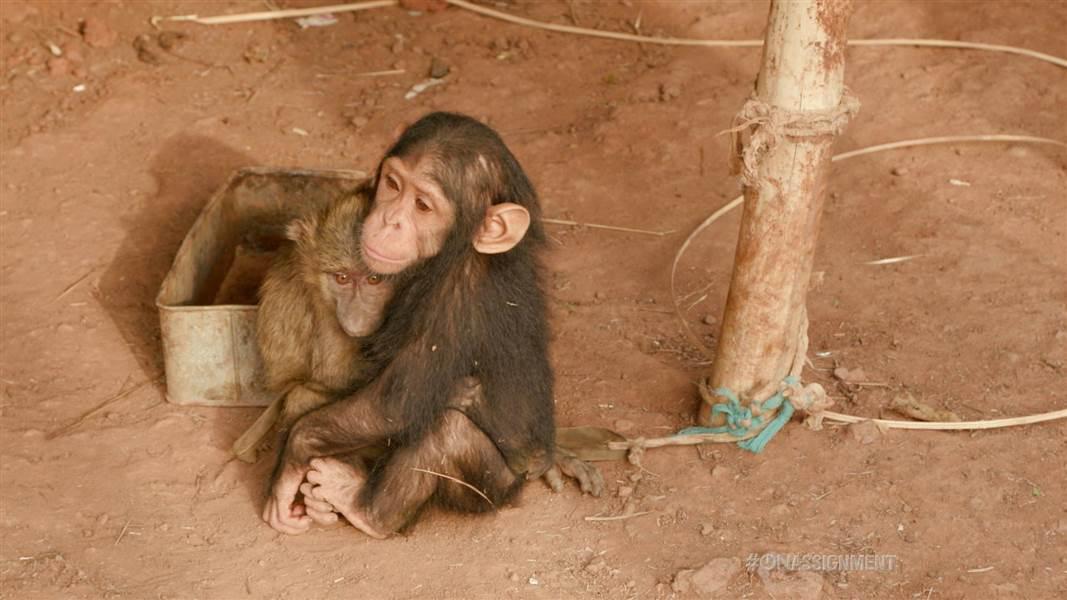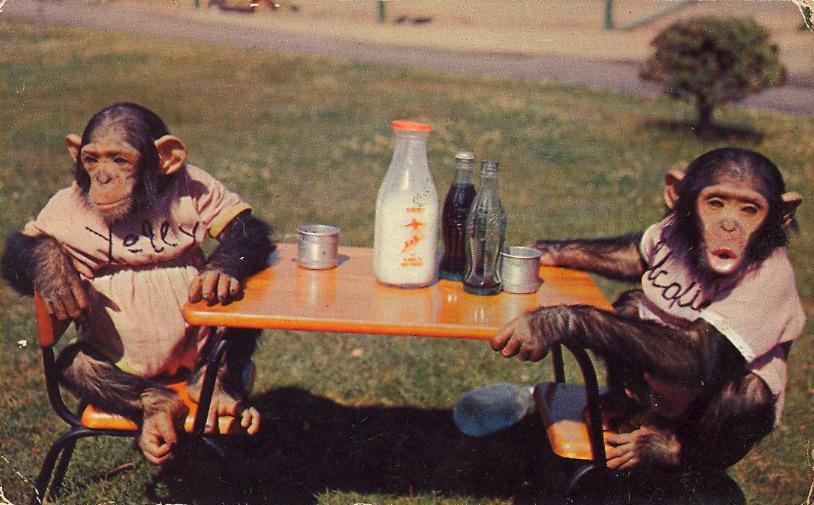The first image is the image on the left, the second image is the image on the right. For the images shown, is this caption "One image shows multiple chimps gathered around a prone figure on the ground in a clearing." true? Answer yes or no. No. The first image is the image on the left, the second image is the image on the right. Given the left and right images, does the statement "There is a furniture near a chimpanzee in at least one of the images." hold true? Answer yes or no. Yes. 